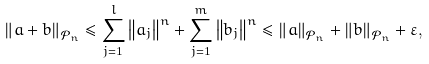Convert formula to latex. <formula><loc_0><loc_0><loc_500><loc_500>\left \| a + b \right \| _ { \mathcal { P } _ { n } } \leq \sum _ { j = 1 } ^ { l } \left \| a _ { j } \right \| ^ { n } + \sum _ { j = 1 } ^ { m } \left \| b _ { j } \right \| ^ { n } \leq \left \| a \right \| _ { \mathcal { P } _ { n } } + \left \| b \right \| _ { \mathcal { P } _ { n } } + \varepsilon ,</formula> 